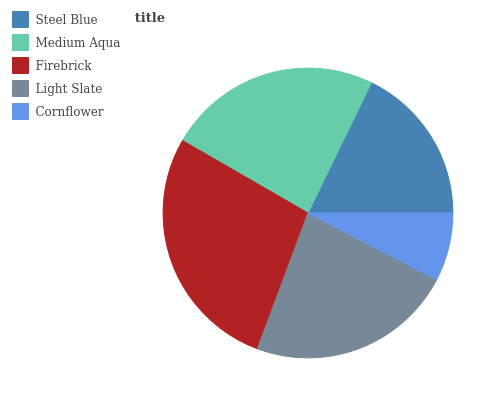Is Cornflower the minimum?
Answer yes or no. Yes. Is Firebrick the maximum?
Answer yes or no. Yes. Is Medium Aqua the minimum?
Answer yes or no. No. Is Medium Aqua the maximum?
Answer yes or no. No. Is Medium Aqua greater than Steel Blue?
Answer yes or no. Yes. Is Steel Blue less than Medium Aqua?
Answer yes or no. Yes. Is Steel Blue greater than Medium Aqua?
Answer yes or no. No. Is Medium Aqua less than Steel Blue?
Answer yes or no. No. Is Light Slate the high median?
Answer yes or no. Yes. Is Light Slate the low median?
Answer yes or no. Yes. Is Cornflower the high median?
Answer yes or no. No. Is Steel Blue the low median?
Answer yes or no. No. 